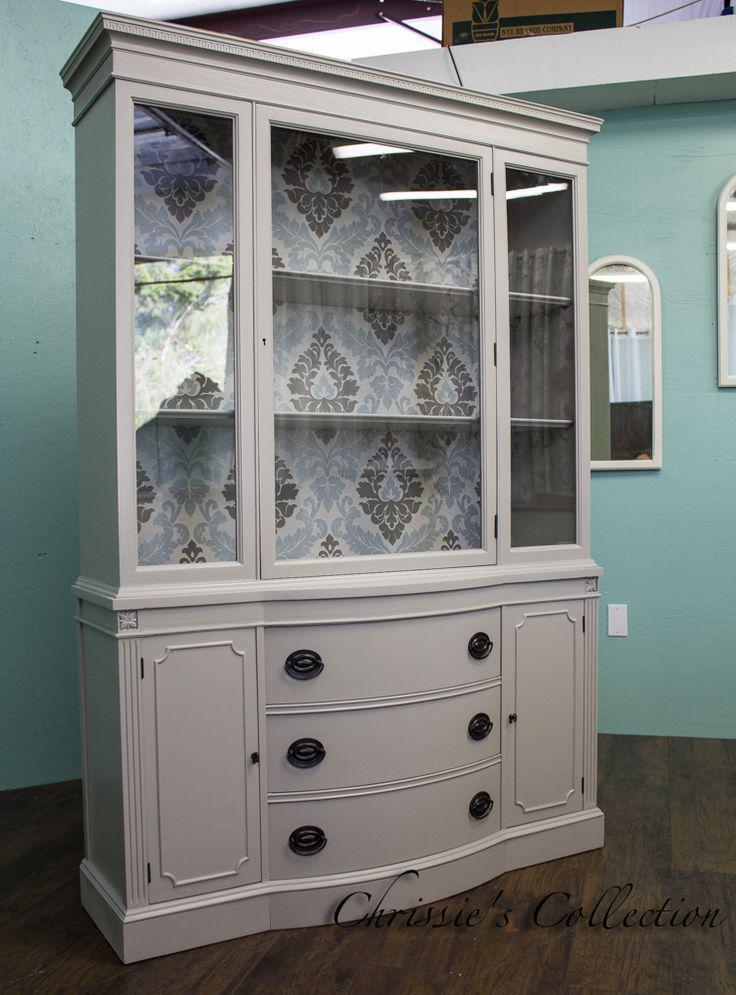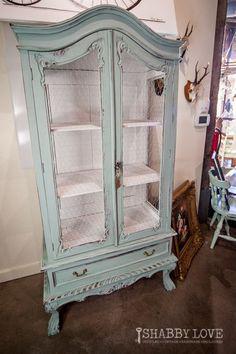The first image is the image on the left, the second image is the image on the right. Analyze the images presented: Is the assertion "One image shows a pale blue shabby chic cabinet with a shaped element on top and a two-handled drawer under the glass doors." valid? Answer yes or no. Yes. The first image is the image on the left, the second image is the image on the right. Considering the images on both sides, is "A wooded hutch with a curved top stands on feet, while a second hutch has a straight top and sits flush to the floor." valid? Answer yes or no. Yes. 